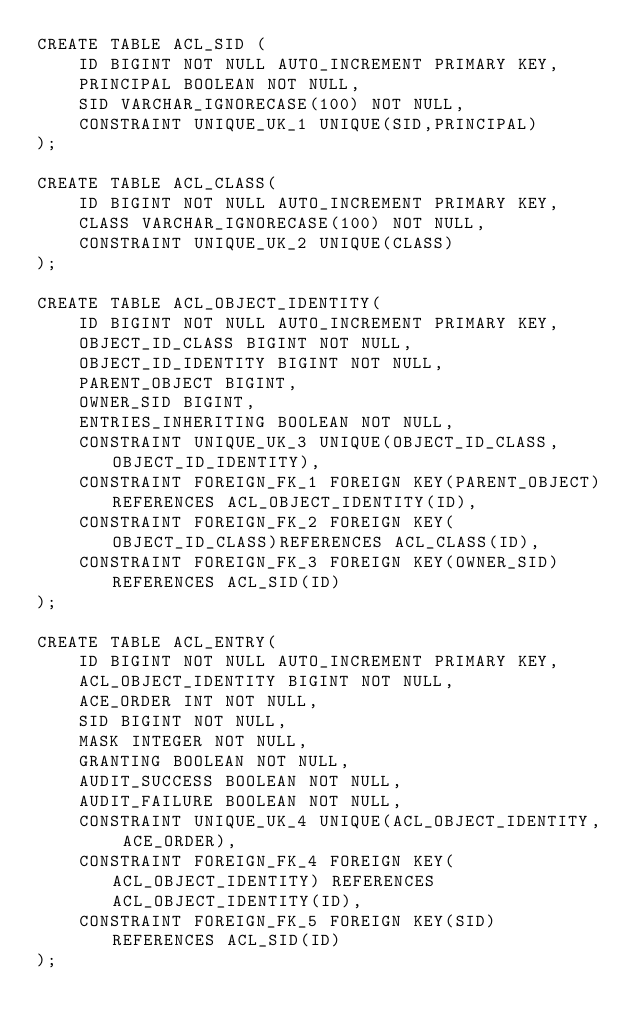<code> <loc_0><loc_0><loc_500><loc_500><_SQL_>CREATE TABLE ACL_SID (
    ID BIGINT NOT NULL AUTO_INCREMENT PRIMARY KEY,
    PRINCIPAL BOOLEAN NOT NULL,
    SID VARCHAR_IGNORECASE(100) NOT NULL,
    CONSTRAINT UNIQUE_UK_1 UNIQUE(SID,PRINCIPAL)
);

CREATE TABLE ACL_CLASS(
    ID BIGINT NOT NULL AUTO_INCREMENT PRIMARY KEY,
    CLASS VARCHAR_IGNORECASE(100) NOT NULL,
    CONSTRAINT UNIQUE_UK_2 UNIQUE(CLASS)
);

CREATE TABLE ACL_OBJECT_IDENTITY(
    ID BIGINT NOT NULL AUTO_INCREMENT PRIMARY KEY,
    OBJECT_ID_CLASS BIGINT NOT NULL,
    OBJECT_ID_IDENTITY BIGINT NOT NULL,
    PARENT_OBJECT BIGINT,
    OWNER_SID BIGINT,
    ENTRIES_INHERITING BOOLEAN NOT NULL,
    CONSTRAINT UNIQUE_UK_3 UNIQUE(OBJECT_ID_CLASS, OBJECT_ID_IDENTITY),
    CONSTRAINT FOREIGN_FK_1 FOREIGN KEY(PARENT_OBJECT)REFERENCES ACL_OBJECT_IDENTITY(ID),
    CONSTRAINT FOREIGN_FK_2 FOREIGN KEY(OBJECT_ID_CLASS)REFERENCES ACL_CLASS(ID),
    CONSTRAINT FOREIGN_FK_3 FOREIGN KEY(OWNER_SID)REFERENCES ACL_SID(ID)
);

CREATE TABLE ACL_ENTRY(
    ID BIGINT NOT NULL AUTO_INCREMENT PRIMARY KEY,
    ACL_OBJECT_IDENTITY BIGINT NOT NULL,
    ACE_ORDER INT NOT NULL,
    SID BIGINT NOT NULL,
    MASK INTEGER NOT NULL,
    GRANTING BOOLEAN NOT NULL,
    AUDIT_SUCCESS BOOLEAN NOT NULL,
    AUDIT_FAILURE BOOLEAN NOT NULL,
    CONSTRAINT UNIQUE_UK_4 UNIQUE(ACL_OBJECT_IDENTITY, ACE_ORDER),
    CONSTRAINT FOREIGN_FK_4 FOREIGN KEY(ACL_OBJECT_IDENTITY) REFERENCES ACL_OBJECT_IDENTITY(ID),
    CONSTRAINT FOREIGN_FK_5 FOREIGN KEY(SID) REFERENCES ACL_SID(ID)
);
</code> 